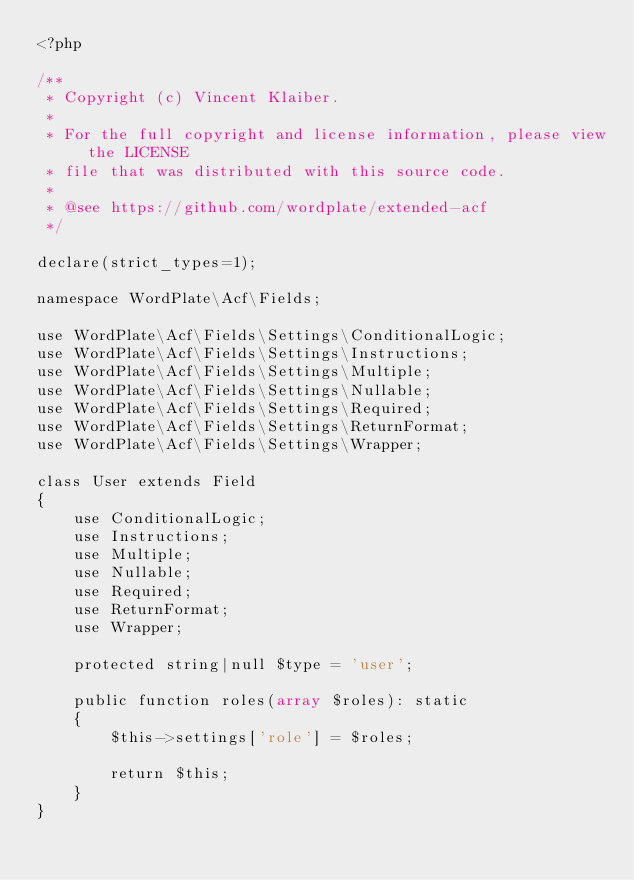Convert code to text. <code><loc_0><loc_0><loc_500><loc_500><_PHP_><?php

/**
 * Copyright (c) Vincent Klaiber.
 *
 * For the full copyright and license information, please view the LICENSE
 * file that was distributed with this source code.
 *
 * @see https://github.com/wordplate/extended-acf
 */

declare(strict_types=1);

namespace WordPlate\Acf\Fields;

use WordPlate\Acf\Fields\Settings\ConditionalLogic;
use WordPlate\Acf\Fields\Settings\Instructions;
use WordPlate\Acf\Fields\Settings\Multiple;
use WordPlate\Acf\Fields\Settings\Nullable;
use WordPlate\Acf\Fields\Settings\Required;
use WordPlate\Acf\Fields\Settings\ReturnFormat;
use WordPlate\Acf\Fields\Settings\Wrapper;

class User extends Field
{
    use ConditionalLogic;
    use Instructions;
    use Multiple;
    use Nullable;
    use Required;
    use ReturnFormat;
    use Wrapper;

    protected string|null $type = 'user';

    public function roles(array $roles): static
    {
        $this->settings['role'] = $roles;

        return $this;
    }
}
</code> 